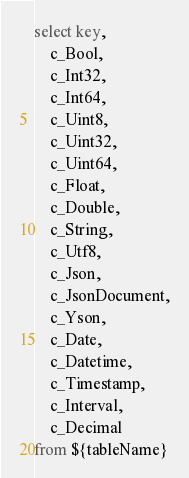Convert code to text. <code><loc_0><loc_0><loc_500><loc_500><_SQL_>select key,
    c_Bool,
    c_Int32,
    c_Int64,
    c_Uint8,
    c_Uint32,
    c_Uint64,
    c_Float,
    c_Double,
    c_String,
    c_Utf8,
    c_Json,
    c_JsonDocument,
    c_Yson,
    c_Date,
    c_Datetime,
    c_Timestamp,
    c_Interval,
    c_Decimal
from ${tableName}
</code> 